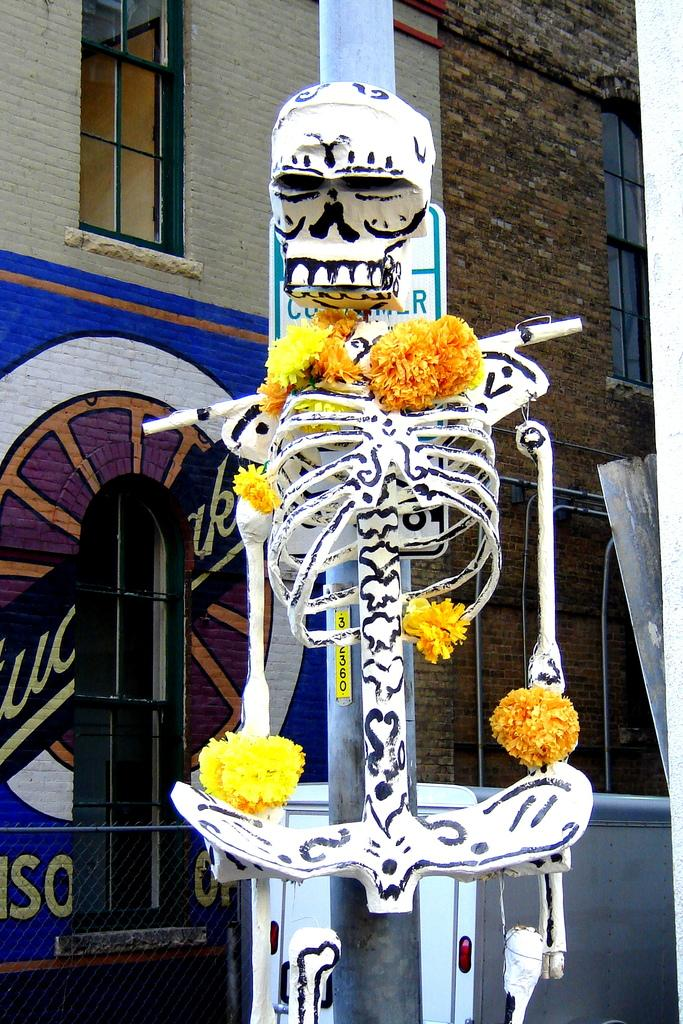What is the main subject of the image? There is a skeleton in the image. What is unique about the skeleton in the image? The skeleton has flowers associated with it. What can be seen in the background of the image? There is a building and a pole in the background of the image. What features can be observed on the building? The building has windows. What type of hall can be seen in the image? There is no hall present in the image; it features a skeleton with flowers and a building with windows in the background. What time of day is depicted in the image? The time of day cannot be determined from the image, as there are no specific indicators of day or night. 